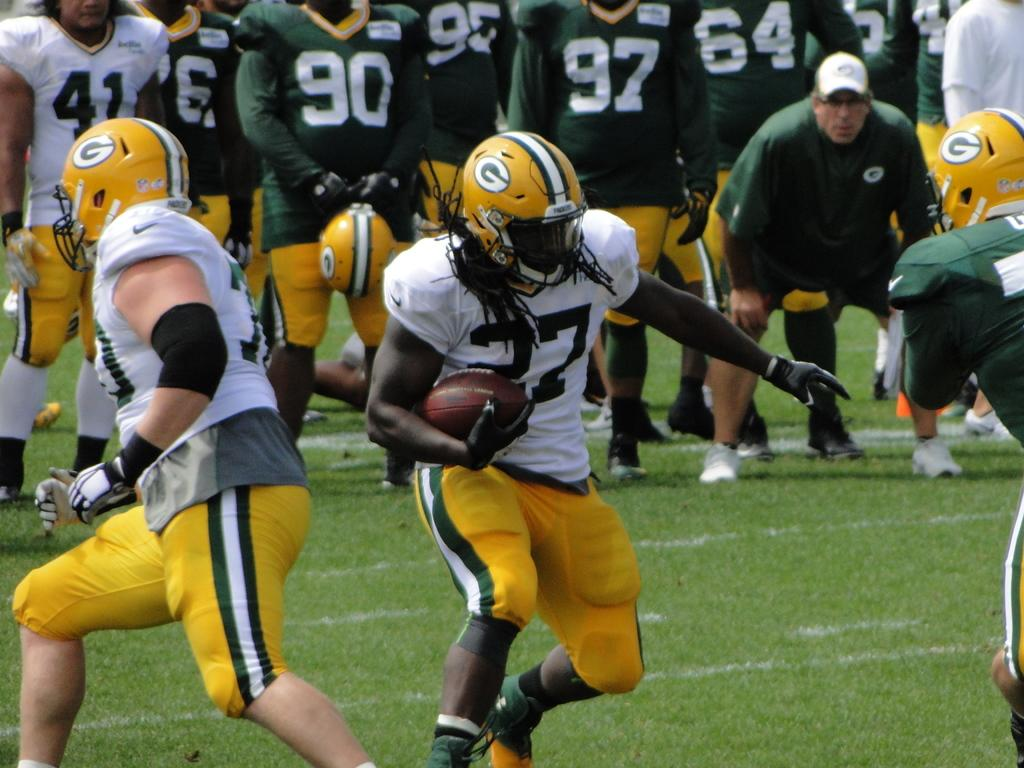What are the people in the image doing? The people in the image are playing American football. What type of surface is visible at the bottom of the image? There is grass at the bottom of the image. What type of texture can be seen on the ants in the image? There are no ants present in the image, so it is not possible to determine their texture. 